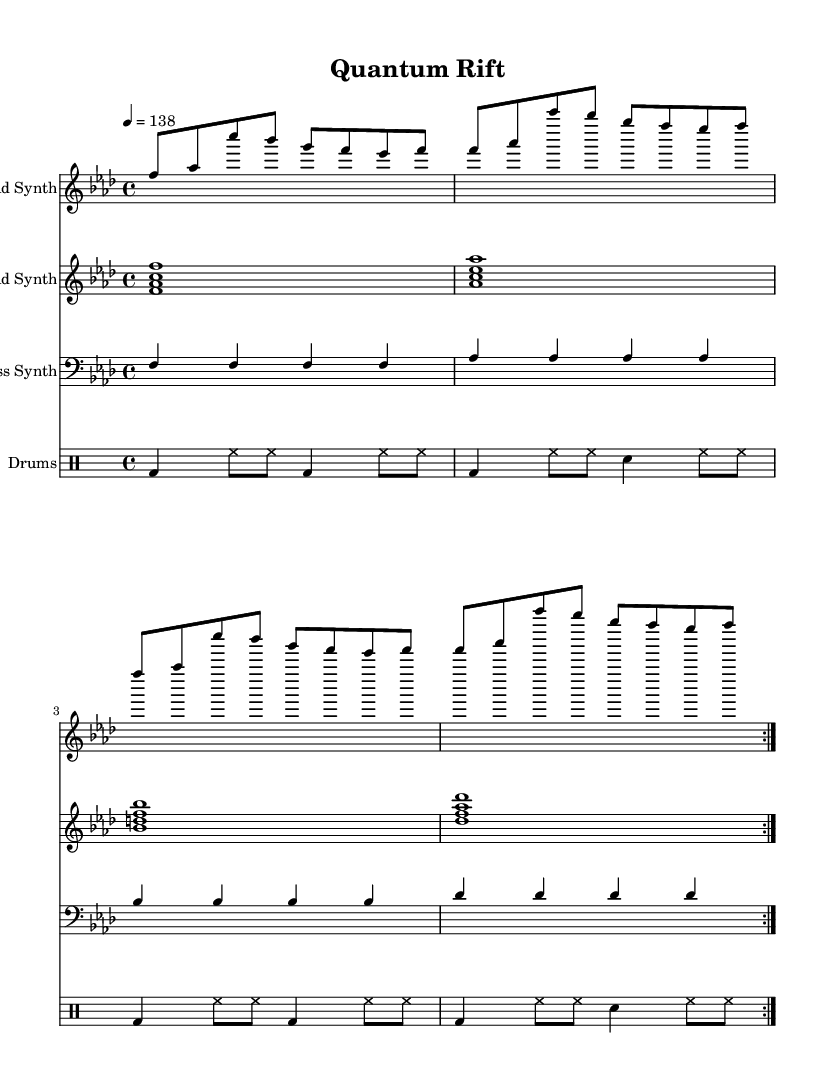What is the key signature of this music? The key signature is F minor, which has four flats. In the sheet music, a flat symbol is indicated on the staff for B, E, A, and D.
Answer: F minor What is the time signature of this music? The time signature is 4/4, indicated at the beginning of the staff. This means there are four beats in a measure, and the quarter note gets one beat.
Answer: 4/4 What is the tempo marking for this piece? The tempo marking is 138, as stated in the tempo indication at the beginning. This indicates the speed of the music in beats per minute.
Answer: 138 How many times is the lead synth pattern repeated? The lead synth pattern is repeated 2 times, as indicated by the 'volta 2' instruction in the code, which specifies that the section should be played twice.
Answer: 2 times What note is played in the bass synth during the first measure? The bass synth plays the note F in the first measure, as shown in the sheet music where the first note in the bass staff is F.
Answer: F What chords are played by the pad synth in the second measure? The pad synth plays the chord A flat, C, E flat, and A flat in the second measure, confirming this by looking at the notes presented in that measure on the staff.
Answer: A flat, C, E flat, A flat How does the rhythm of the drums change in the third measure? The rhythm of the drums changes in the third measure by including a snare hit on the third beat instead of a bass drum, which can be observed by comparing the rhythmic notation in each measure.
Answer: Snare hit on the third beat 